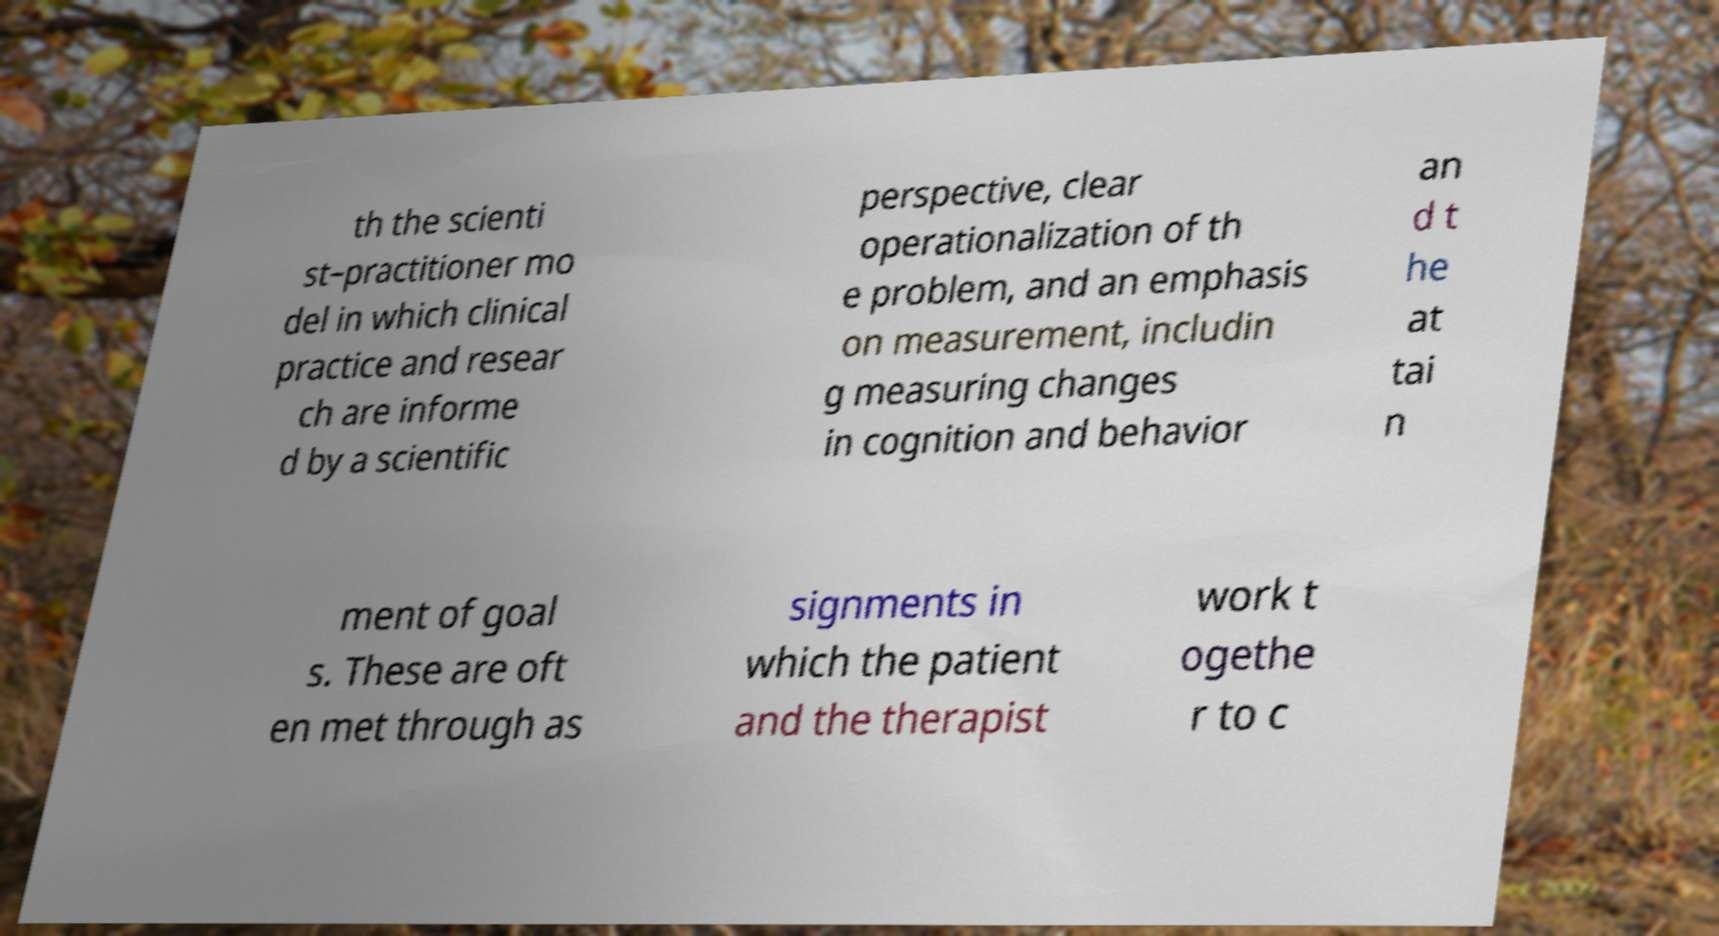Could you assist in decoding the text presented in this image and type it out clearly? th the scienti st–practitioner mo del in which clinical practice and resear ch are informe d by a scientific perspective, clear operationalization of th e problem, and an emphasis on measurement, includin g measuring changes in cognition and behavior an d t he at tai n ment of goal s. These are oft en met through as signments in which the patient and the therapist work t ogethe r to c 